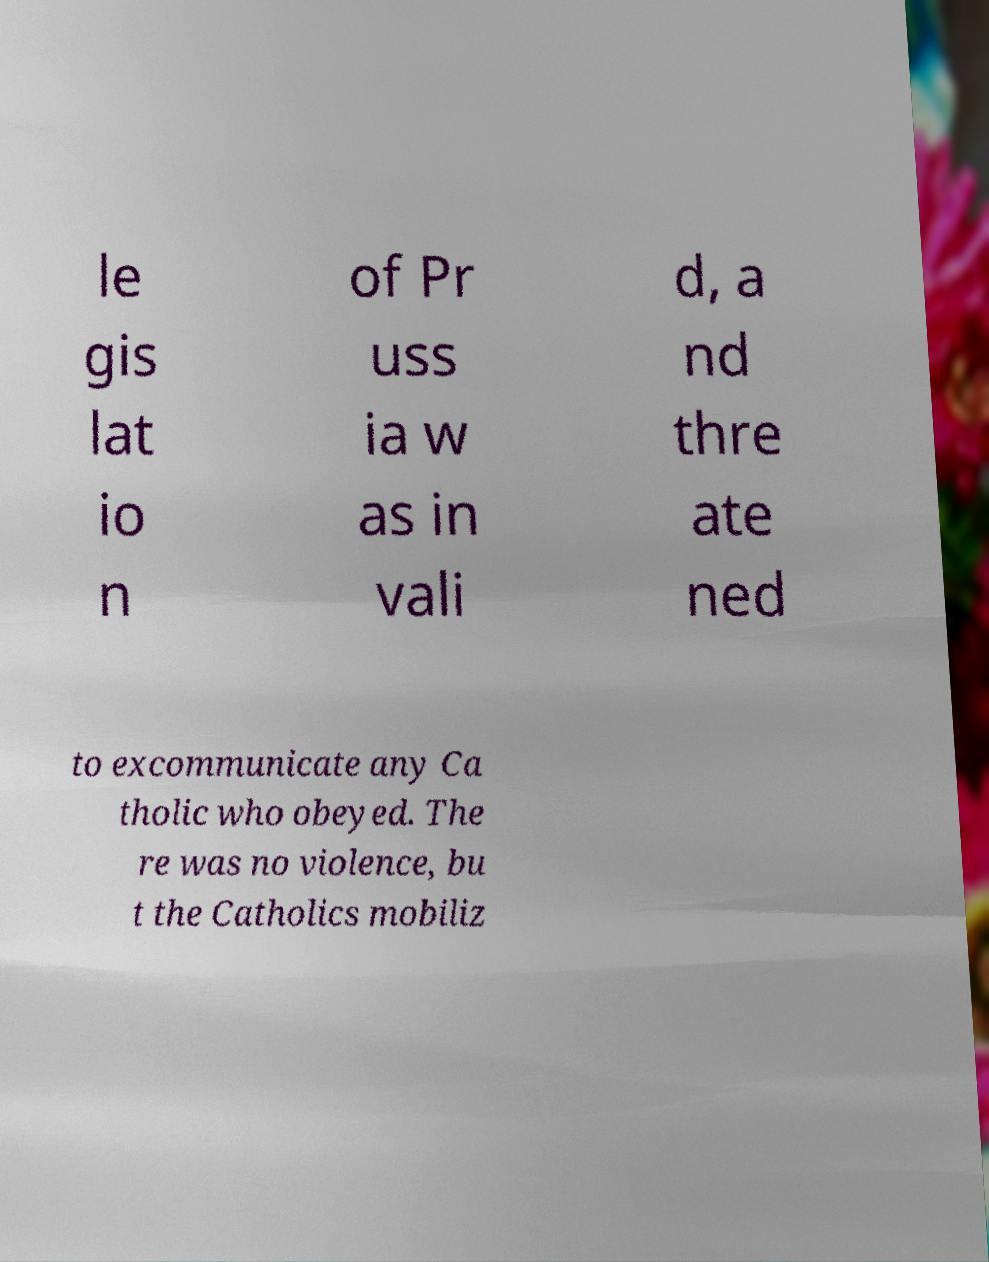Could you assist in decoding the text presented in this image and type it out clearly? le gis lat io n of Pr uss ia w as in vali d, a nd thre ate ned to excommunicate any Ca tholic who obeyed. The re was no violence, bu t the Catholics mobiliz 